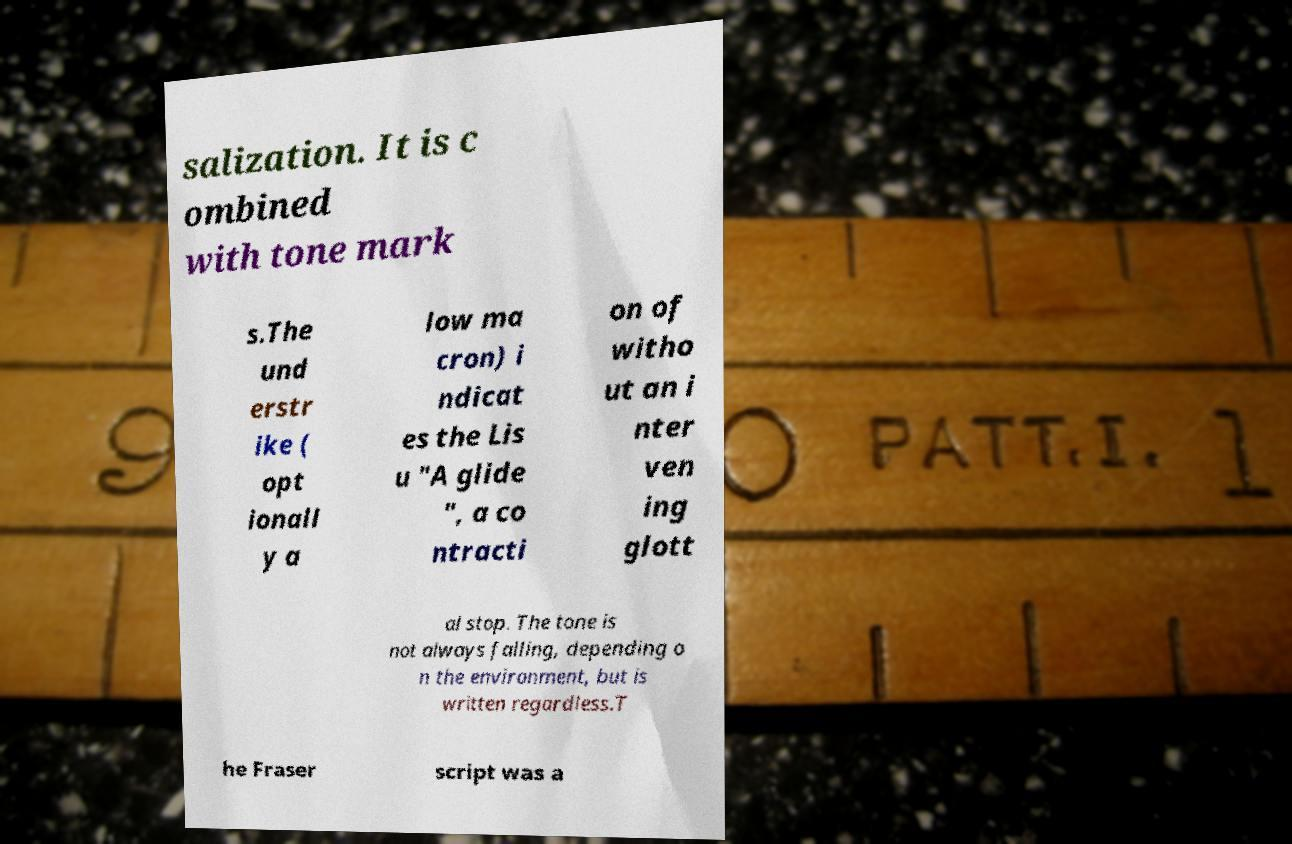Can you read and provide the text displayed in the image?This photo seems to have some interesting text. Can you extract and type it out for me? salization. It is c ombined with tone mark s.The und erstr ike ( opt ionall y a low ma cron) i ndicat es the Lis u "A glide ", a co ntracti on of witho ut an i nter ven ing glott al stop. The tone is not always falling, depending o n the environment, but is written regardless.T he Fraser script was a 